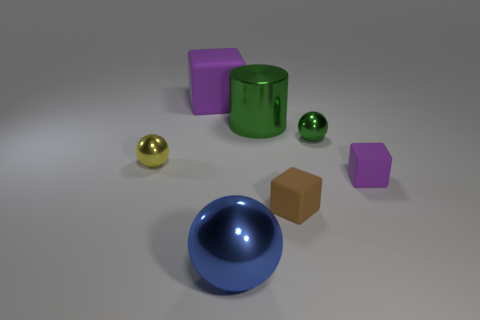Can you tell me how many objects there are on the surface and describe their colors? There are seven objects arranged on the surface. From left to right, there's a purple cube, a large green cylinder, a small green sphere, a large blue hemisphere, a small yellow metal ball, a brown cube, and another purple cube. 